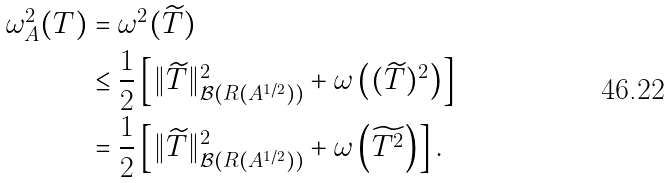<formula> <loc_0><loc_0><loc_500><loc_500>\omega _ { A } ^ { 2 } ( T ) & = \omega ^ { 2 } ( \widetilde { T } ) \\ & \leq \frac { 1 } { 2 } \left [ { \| \widetilde { T } \| _ { \mathcal { B } ( R ( A ^ { 1 / 2 } ) ) } ^ { 2 } + \omega \left ( { ( \widetilde { T } ) ^ { 2 } } \right ) } \right ] \\ & = \frac { 1 } { 2 } \left [ { \| \widetilde { T } \| _ { \mathcal { B } ( R ( A ^ { 1 / 2 } ) ) } ^ { 2 } + \omega \left ( { \widetilde { T ^ { 2 } } } \right ) } \right ] .</formula> 